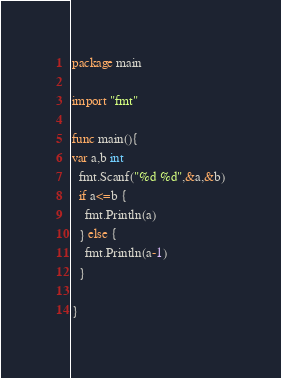Convert code to text. <code><loc_0><loc_0><loc_500><loc_500><_Go_>package main

import "fmt"

func main(){
var a,b int
  fmt.Scanf("%d %d",&a,&b)
  if a<=b {
    fmt.Println(a)
  } else {
    fmt.Println(a-1)
  }

}</code> 